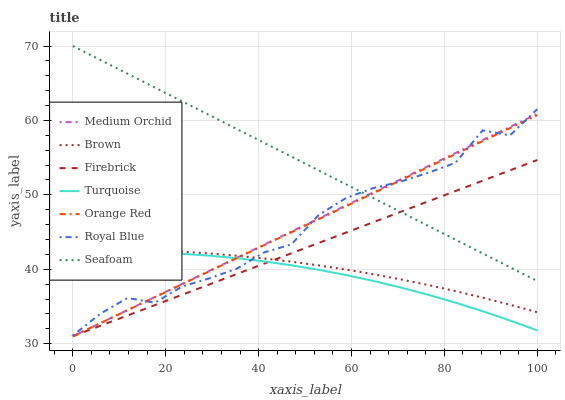Does Turquoise have the minimum area under the curve?
Answer yes or no. Yes. Does Seafoam have the maximum area under the curve?
Answer yes or no. Yes. Does Firebrick have the minimum area under the curve?
Answer yes or no. No. Does Firebrick have the maximum area under the curve?
Answer yes or no. No. Is Medium Orchid the smoothest?
Answer yes or no. Yes. Is Royal Blue the roughest?
Answer yes or no. Yes. Is Turquoise the smoothest?
Answer yes or no. No. Is Turquoise the roughest?
Answer yes or no. No. Does Firebrick have the lowest value?
Answer yes or no. Yes. Does Turquoise have the lowest value?
Answer yes or no. No. Does Seafoam have the highest value?
Answer yes or no. Yes. Does Firebrick have the highest value?
Answer yes or no. No. Is Brown less than Seafoam?
Answer yes or no. Yes. Is Seafoam greater than Brown?
Answer yes or no. Yes. Does Orange Red intersect Seafoam?
Answer yes or no. Yes. Is Orange Red less than Seafoam?
Answer yes or no. No. Is Orange Red greater than Seafoam?
Answer yes or no. No. Does Brown intersect Seafoam?
Answer yes or no. No. 